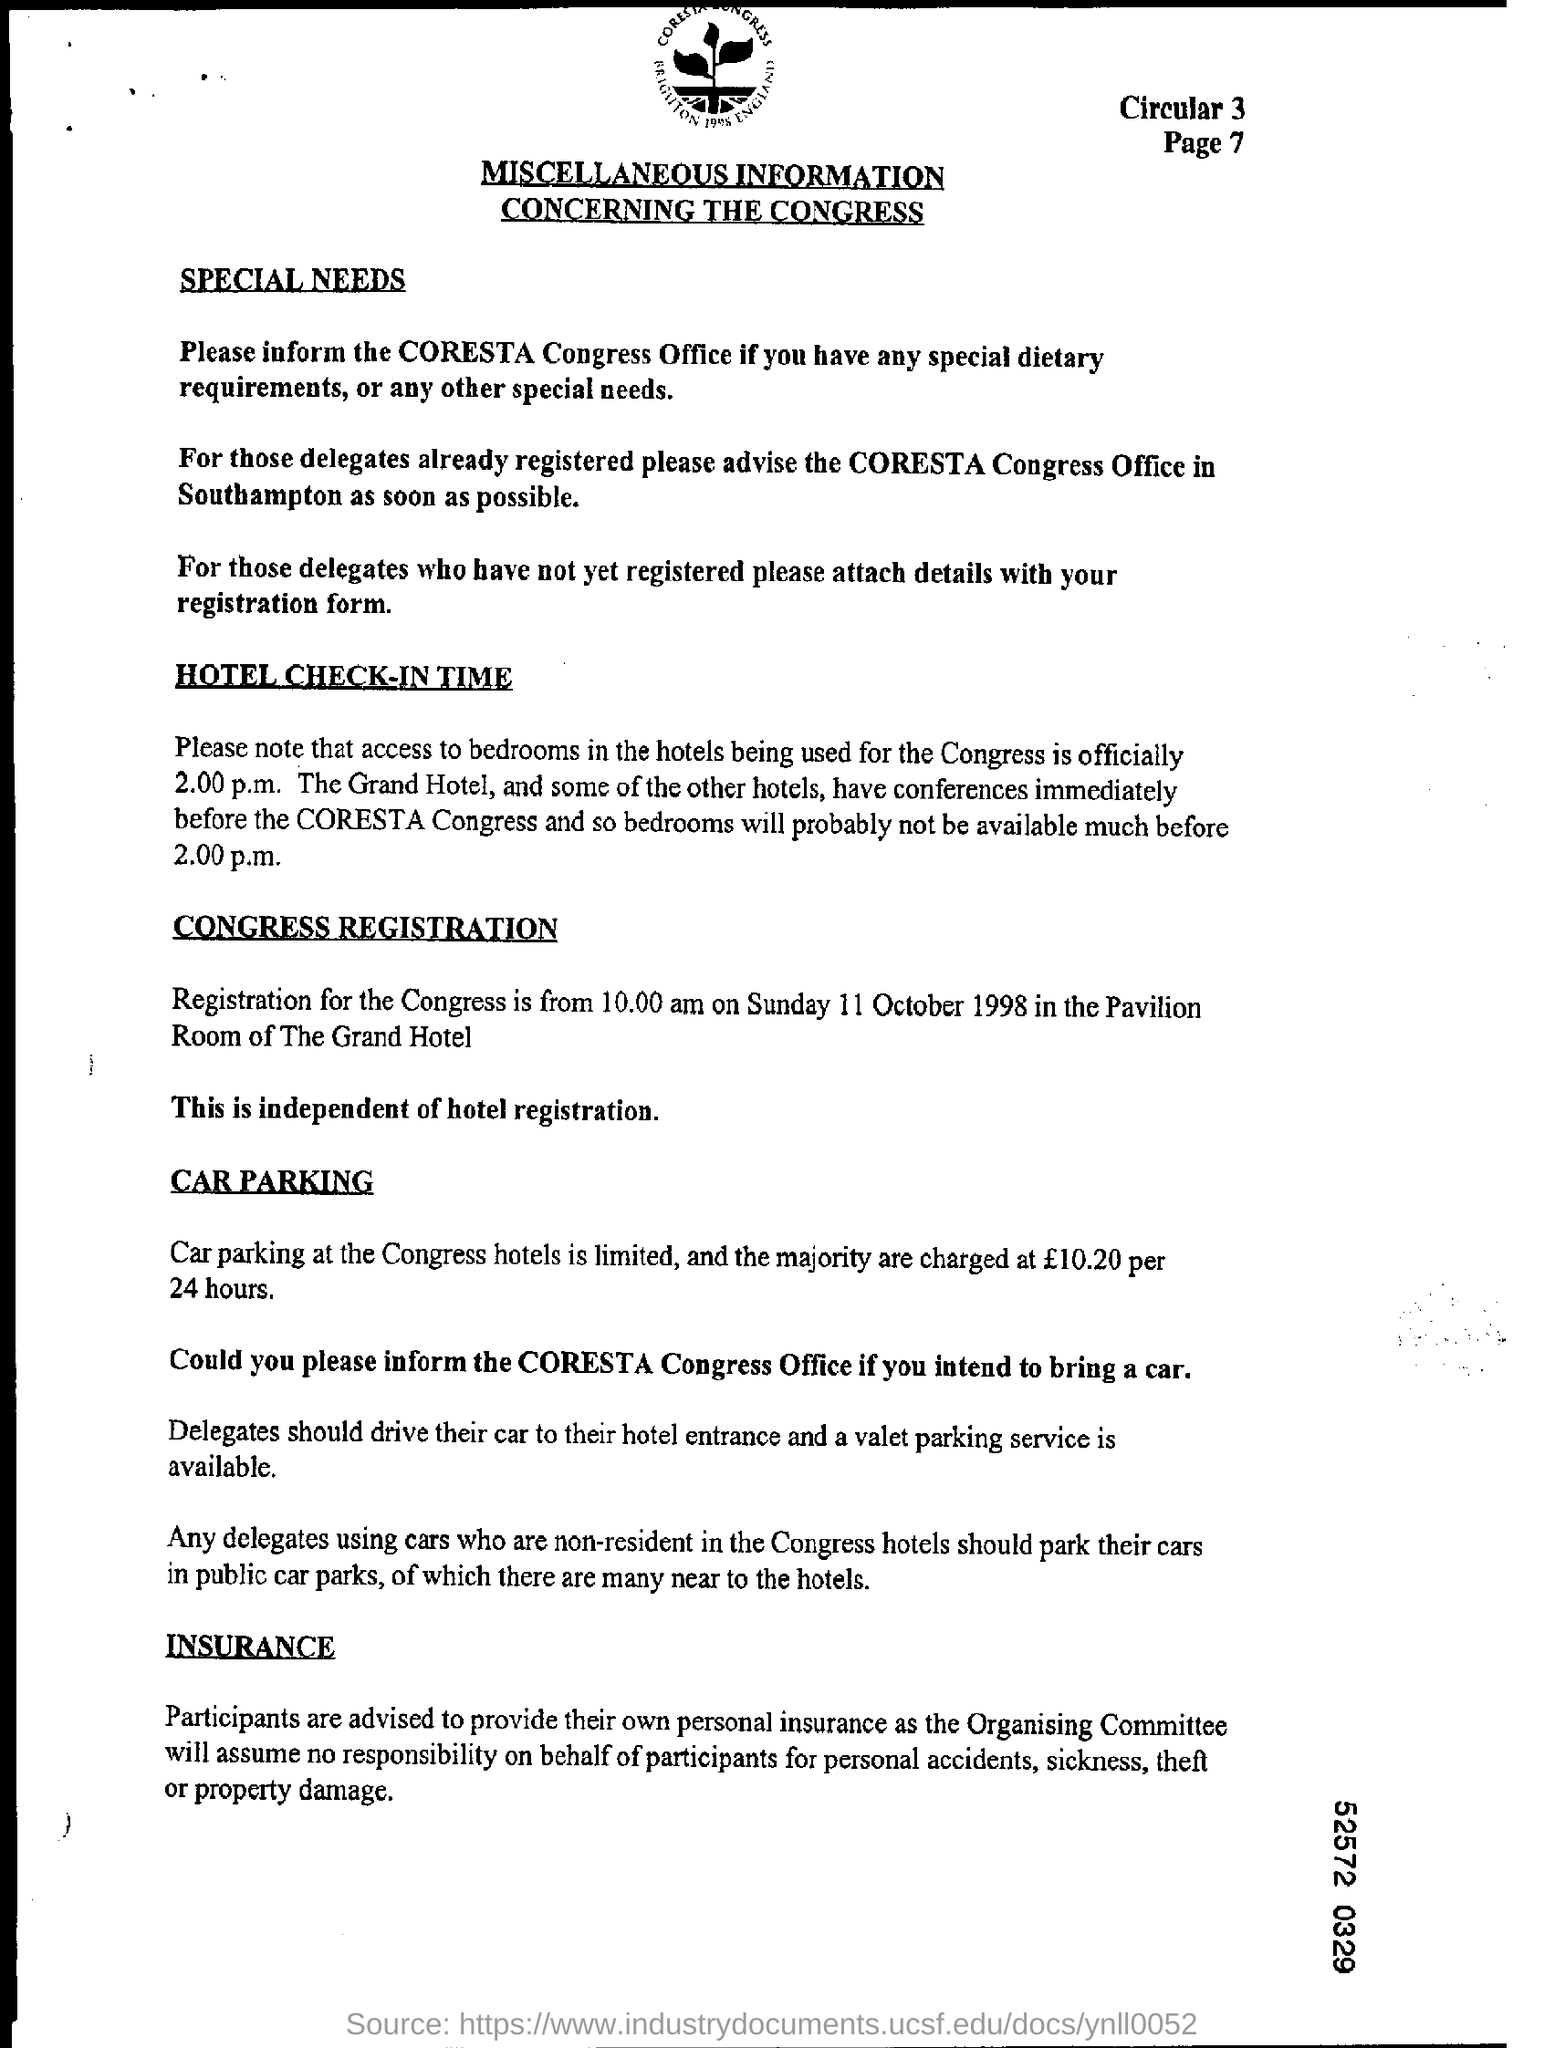List a handful of essential elements in this visual. If you have any special needs, it is important to inform the CORESTA Congress Office. The Congress Registration is scheduled for Sunday, October 11, 1998. The official access time for bedrooms used by the Congress is 2.00 p.m. The location of the Congress Registration will take place in the Pavilion Room of The Grand Hotel. This document is titled 'MISCELLANEOUS INFORMATION CONCERNING THE CONGRESS.' 